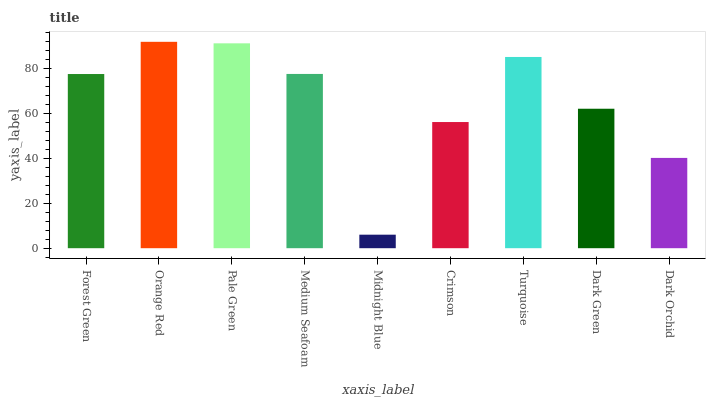Is Midnight Blue the minimum?
Answer yes or no. Yes. Is Orange Red the maximum?
Answer yes or no. Yes. Is Pale Green the minimum?
Answer yes or no. No. Is Pale Green the maximum?
Answer yes or no. No. Is Orange Red greater than Pale Green?
Answer yes or no. Yes. Is Pale Green less than Orange Red?
Answer yes or no. Yes. Is Pale Green greater than Orange Red?
Answer yes or no. No. Is Orange Red less than Pale Green?
Answer yes or no. No. Is Forest Green the high median?
Answer yes or no. Yes. Is Forest Green the low median?
Answer yes or no. Yes. Is Turquoise the high median?
Answer yes or no. No. Is Crimson the low median?
Answer yes or no. No. 